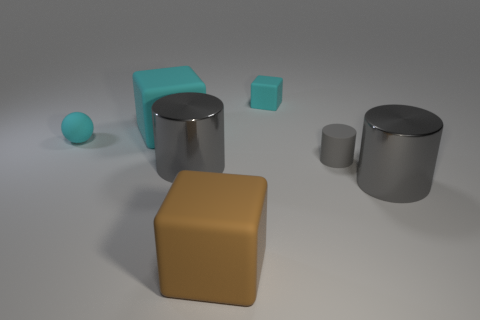Add 2 brown rubber things. How many objects exist? 9 Add 4 cyan objects. How many cyan objects exist? 7 Subtract all brown blocks. How many blocks are left? 2 Subtract all large gray cylinders. How many cylinders are left? 1 Subtract 0 yellow cylinders. How many objects are left? 7 Subtract all cubes. How many objects are left? 4 Subtract 1 spheres. How many spheres are left? 0 Subtract all yellow blocks. Subtract all brown cylinders. How many blocks are left? 3 Subtract all cyan spheres. How many cyan cubes are left? 2 Subtract all brown cubes. Subtract all cyan rubber balls. How many objects are left? 5 